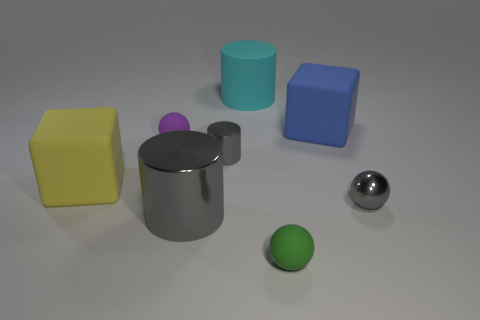Does the large gray metal object have the same shape as the small purple object?
Provide a succinct answer. No. How many shiny objects are either large blue objects or large yellow objects?
Give a very brief answer. 0. What number of big gray cylinders are there?
Keep it short and to the point. 1. There is a cylinder that is the same size as the green rubber thing; what color is it?
Make the answer very short. Gray. Does the shiny sphere have the same size as the yellow thing?
Offer a very short reply. No. What is the shape of the small metal object that is the same color as the tiny metal cylinder?
Offer a terse response. Sphere. Is the size of the purple rubber sphere the same as the matte block behind the large yellow rubber thing?
Provide a short and direct response. No. There is a tiny object that is behind the yellow object and in front of the purple object; what is its color?
Ensure brevity in your answer.  Gray. Is the number of big yellow matte objects that are behind the tiny purple thing greater than the number of large cyan rubber cylinders that are in front of the large blue matte object?
Your answer should be compact. No. What size is the green thing that is the same material as the purple ball?
Your answer should be very brief. Small. 